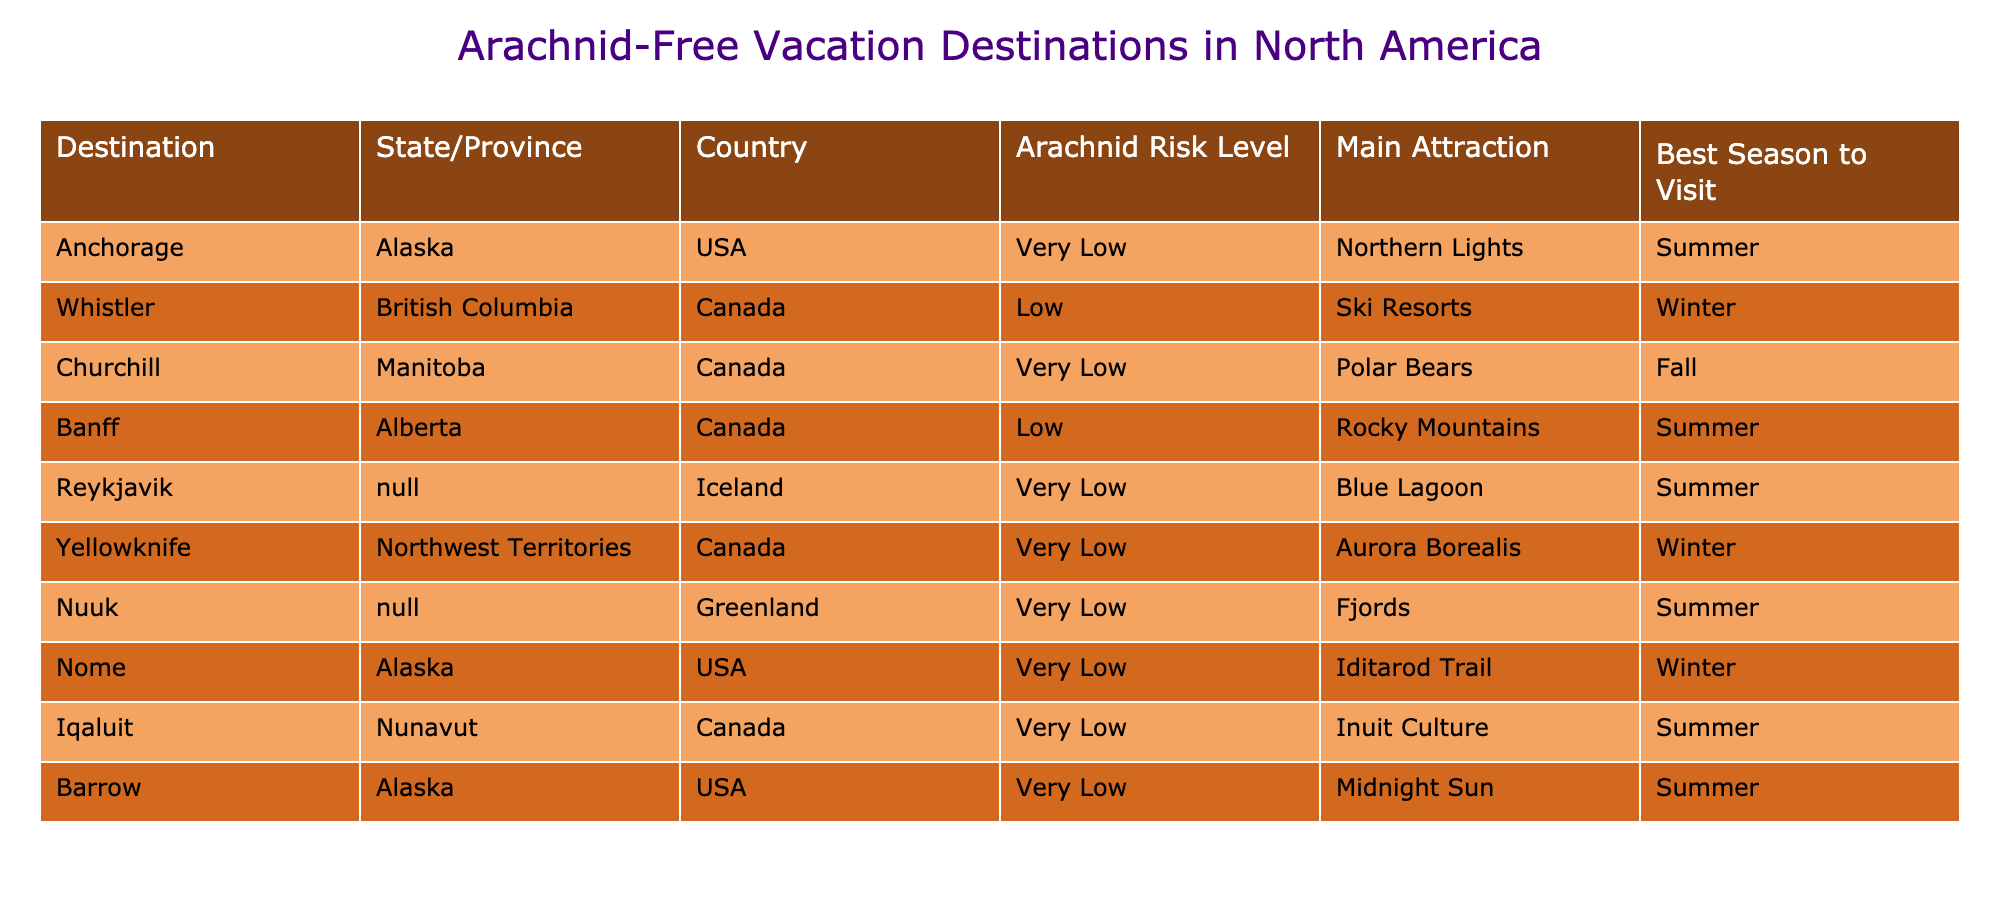What is the main attraction of Barrow, Alaska? The main attraction of Barrow, Alaska is the "Midnight Sun," which can be found in the table under the column "Main Attraction."
Answer: Midnight Sun Which destination has the lowest arachnid risk level? The destinations with the lowest arachnid risk level are Anchorage, Churchill, Yellowknife, Nuuk, Iqaluit, Nome, Barrow, and Reykjavik, as they are all listed as "Very Low" in the "Arachnid Risk Level" column. Each of these locations is safe for arachnophobes.
Answer: Anchorage, Churchill, Yellowknife, Nuuk, Iqaluit, Nome, Barrow, Reykjavik What is the best season to visit Banff, Alberta? The table indicates that the best season to visit Banff, Alberta, is Summer, as specified in the "Best Season to Visit" column.
Answer: Summer Are there any destinations in Greenland? Yes, the table lists Nuuk, Greenland as a destination, confirming that there is at least one location in Greenland.
Answer: Yes How many destinations have a main attraction related to nature (e.g., landscapes, wildlife)? By examining the "Main Attraction" column and considering nature-related attractions, the destinations with such attractions are Churchill (Polar Bears), Banff (Rocky Mountains), Yellowknife (Aurora Borealis), Nuuk (Fjords), and Nome (Iditarod Trail). This makes a total of five destinations.
Answer: 5 What is the ratio of destinations in Canada to those in the USA? In the table, there are six Canadian destinations (Whistler, Churchill, Banff, Yellowknife, Iqaluit, Nuuk) and three US destinations (Anchorage, Nome, Barrow). Therefore, the ratio of Canadian destinations to US destinations is 6:3, which simplifies to 2:1.
Answer: 2:1 Which destination has a main attraction of the Blue Lagoon? The main attraction of the Blue Lagoon is mentioned in the table next to Reykjavik, Iceland. This information can be easily found under the "Main Attraction" column.
Answer: Reykjavik Is there any destination that has a very low arachnid risk level and is located in the winter season? Yes, Nome, Alaska and Yellowknife, Canada both show a very low arachnid risk level and are available to visit in the winter season, as indicated in the "Arachnid Risk Level" and "Best Season to Visit" columns.
Answer: Yes What is the main attraction in Iqaluit, Nunavut? According to the table, the main attraction in Iqaluit, Nunavut is "Inuit Culture," which is listed in the "Main Attraction" column.
Answer: Inuit Culture 